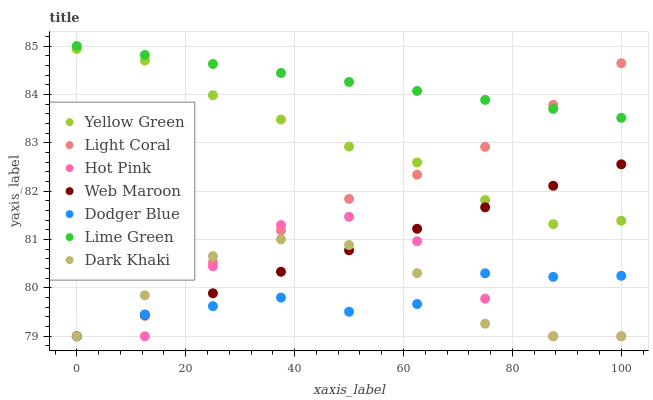Does Dodger Blue have the minimum area under the curve?
Answer yes or no. Yes. Does Lime Green have the maximum area under the curve?
Answer yes or no. Yes. Does Yellow Green have the minimum area under the curve?
Answer yes or no. No. Does Yellow Green have the maximum area under the curve?
Answer yes or no. No. Is Lime Green the smoothest?
Answer yes or no. Yes. Is Hot Pink the roughest?
Answer yes or no. Yes. Is Yellow Green the smoothest?
Answer yes or no. No. Is Yellow Green the roughest?
Answer yes or no. No. Does Dark Khaki have the lowest value?
Answer yes or no. Yes. Does Yellow Green have the lowest value?
Answer yes or no. No. Does Lime Green have the highest value?
Answer yes or no. Yes. Does Yellow Green have the highest value?
Answer yes or no. No. Is Dark Khaki less than Lime Green?
Answer yes or no. Yes. Is Yellow Green greater than Dodger Blue?
Answer yes or no. Yes. Does Dodger Blue intersect Web Maroon?
Answer yes or no. Yes. Is Dodger Blue less than Web Maroon?
Answer yes or no. No. Is Dodger Blue greater than Web Maroon?
Answer yes or no. No. Does Dark Khaki intersect Lime Green?
Answer yes or no. No. 